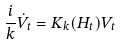Convert formula to latex. <formula><loc_0><loc_0><loc_500><loc_500>\frac { i } { k } \dot { V } _ { t } = K _ { k } ( H _ { t } ) V _ { t }</formula> 